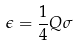<formula> <loc_0><loc_0><loc_500><loc_500>\epsilon = \frac { 1 } { 4 } Q \sigma</formula> 